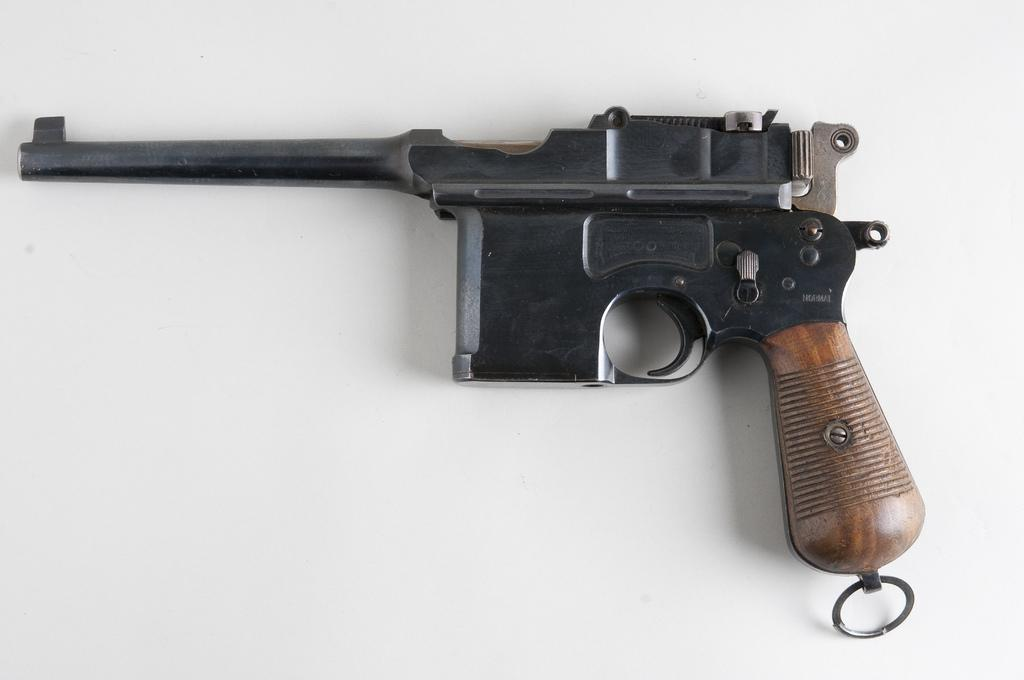What is the main object in the image? There is a gun in the image. What color is the background of the image? The background of the image is white. What type of growth can be seen on the gun in the image? There is no growth visible on the gun in the image. What type of badge is attached to the gun in the image? There is no badge attached to the gun in the image. 